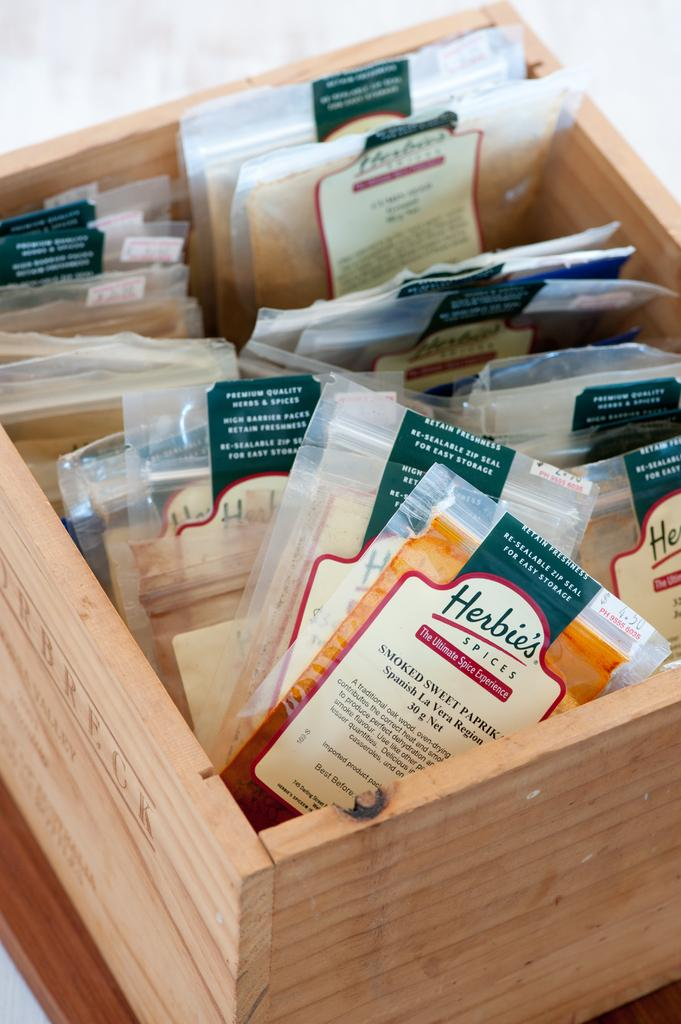<image>
Share a concise interpretation of the image provided. A wooden box of several spices from Herbie's. 